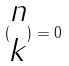Convert formula to latex. <formula><loc_0><loc_0><loc_500><loc_500>( \begin{matrix} n \\ k \end{matrix} ) = 0</formula> 